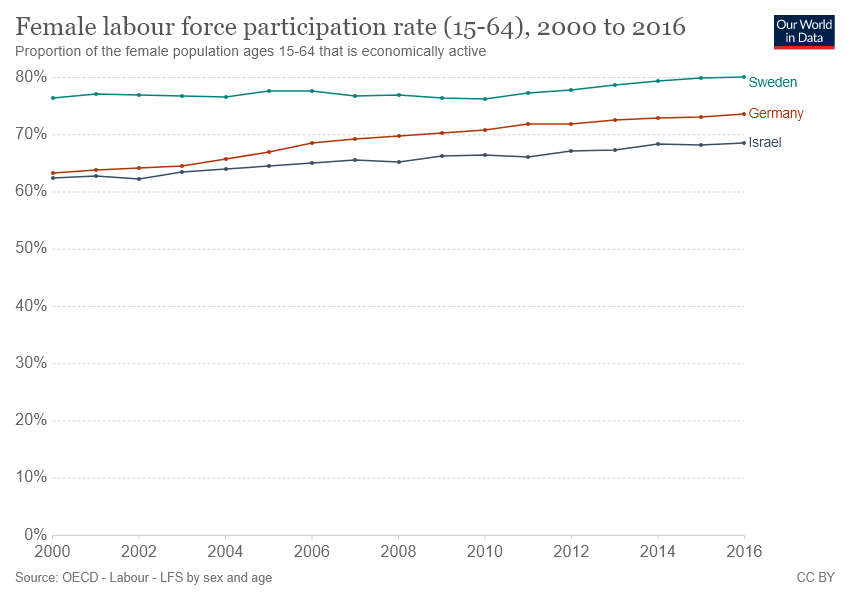List a handful of essential elements in this visual. In 2016, the highest female labor force participation rate was recorded in Germany. The chart shows the labor force participation rates of several countries over time. Of the countries included, only Sweden has a female labor force participation rate of more than 70% throughout the entire graph. 